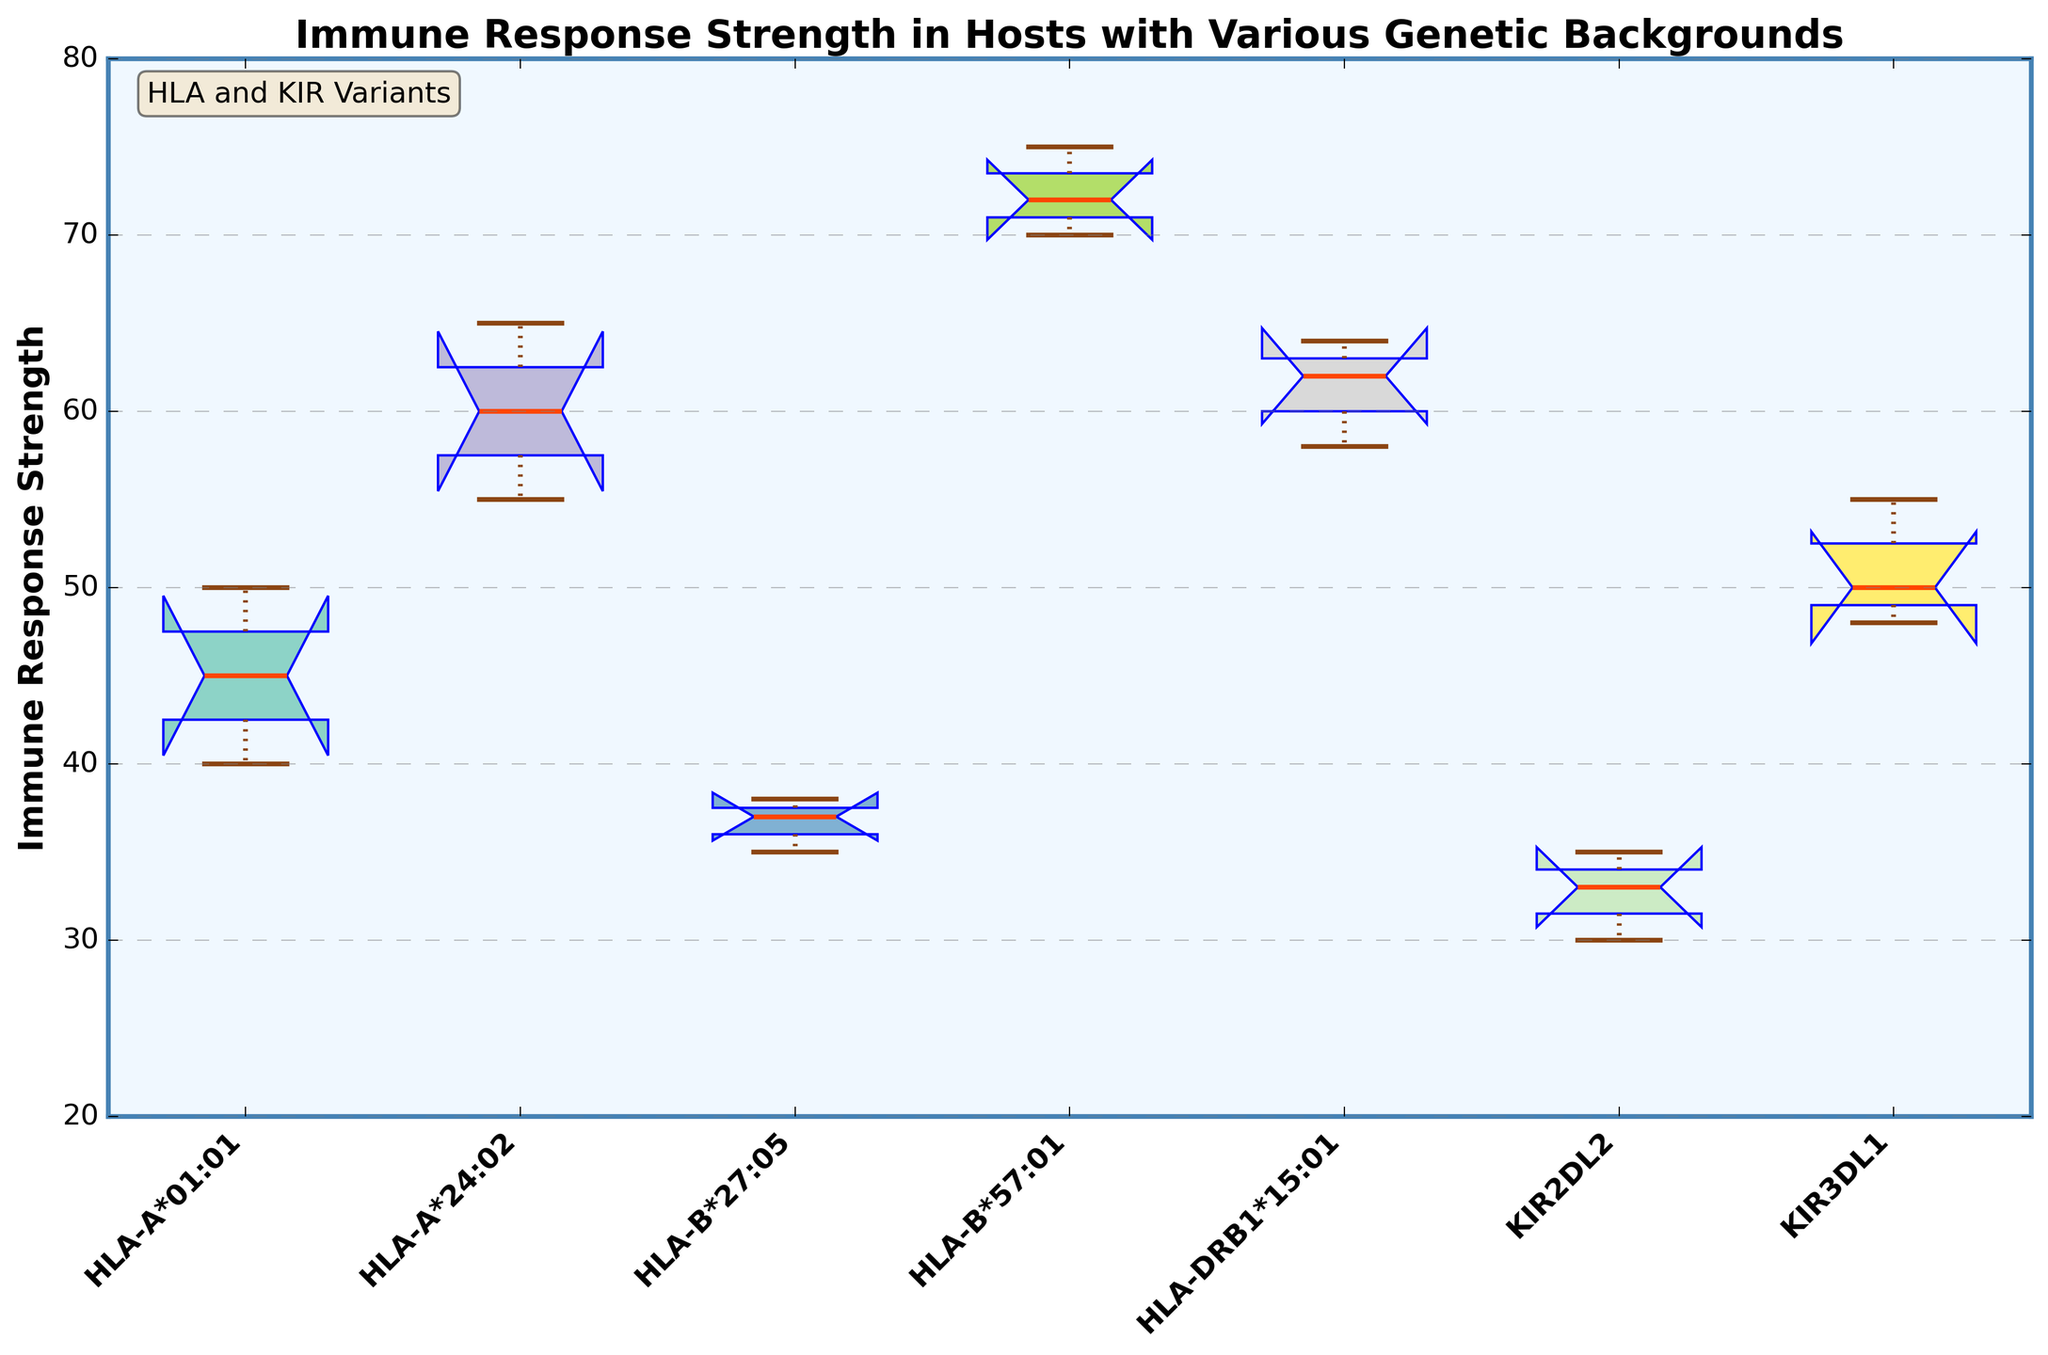Which group has the highest median immune response strength? The median is indicated by the orange line inside each box. The group HLA-B*57:01 has the highest median value, which appears to be around 72.
Answer: HLA-B*57:01 Which group shows the widest interquartile range (IQR) for immune response strength? The IQR is represented by the distance between the lower and upper quartiles (the bottom and top of the box). The group HLA-B*57:01 has the widest box, indicating the largest IQR.
Answer: HLA-B*57:01 How many groups have their median values within the range of 50 to 60? By observing the median lines, groups HLA-DRB1*15:01, HLA-A*24:02, and KIR3DL1 have their medians within the range of 50 to 60.
Answer: 3 Which group has the smallest range of immune response strengths? The range is the difference between the maximum and minimum values (whiskers). The group HLA-B*27:05 has the smallest range, as indicated by the shortest whiskers.
Answer: HLA-B*27:05 What's the median value of the group KIR2DL2? The median value can be found by looking at the line inside the box for KIR2DL2, which is around 33.
Answer: 33 Which group has the lowest immune response strength outlier, and what is its approximate value? The outliers are marked by diamond shapes. The group HLA-B*27:05 has the lowest outlier, which is approximately 35.
Answer: HLA-B*27:05, 35 Are there any groups with notches that do not overlap, indicating a significant difference in their medians? The notches indicate confidence intervals for the medians. HLA-B*57:01 and KIR2DL2 have non-overlapping notches, suggesting a significant difference in their medians.
Answer: Yes How many unique genetic backgrounds are represented in the plot? Each unique color in the box plot corresponds to a unique genetic background, and there are eight different colors/groups.
Answer: 8 What is the immune response strength range for the group HLA-A*24:02? The range is indicated by the positions of the whiskers. For HLA-A*24:02, the range is from about 55 to 65.
Answer: 55 to 65 Which group has the highest maximum immune response strength? The maximum values are indicated by the top whiskers. The group HLA-B*57:01 has the highest maximum value, which is around 75.
Answer: HLA-B*57:01 